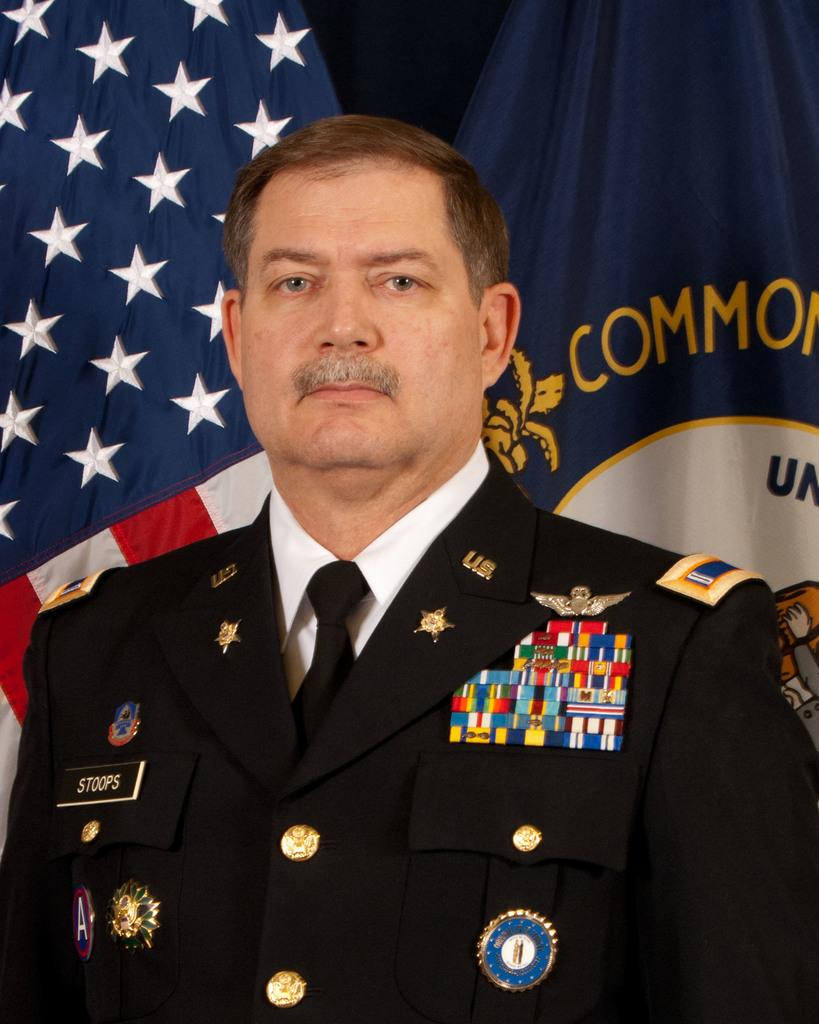What is the person in the image wearing? The person is wearing a black color shirt. What is the person doing in the image? The person is standing. What can be seen in the background of the image? There are two flags in the background of the image. How would you describe the overall color scheme of the background? The background of the image is dark in color. What type of chain can be seen around the person's neck in the image? There is no chain visible around the person's neck in the image. 